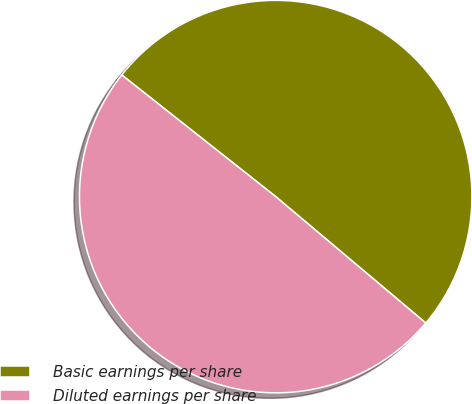Convert chart. <chart><loc_0><loc_0><loc_500><loc_500><pie_chart><fcel>Basic earnings per share<fcel>Diluted earnings per share<nl><fcel>50.5%<fcel>49.5%<nl></chart> 